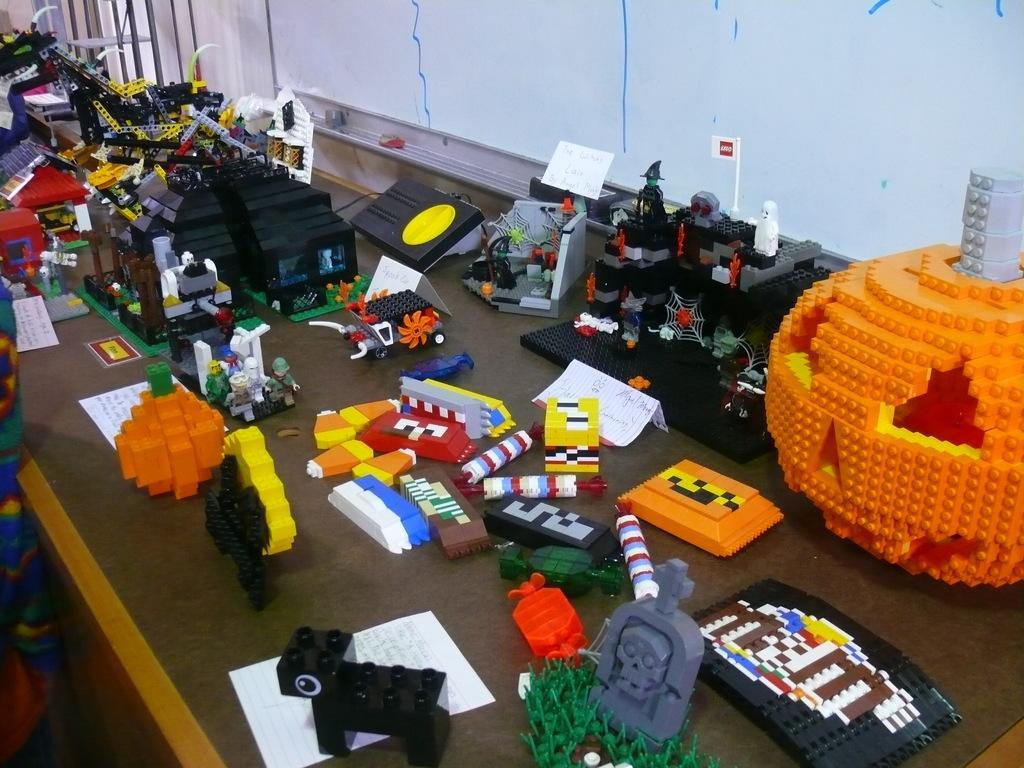How would you summarize this image in a sentence or two? In this image, we can see many toys, papers and we can see some books on the table. In the background, there is a wall and on the left, we can see a person. 